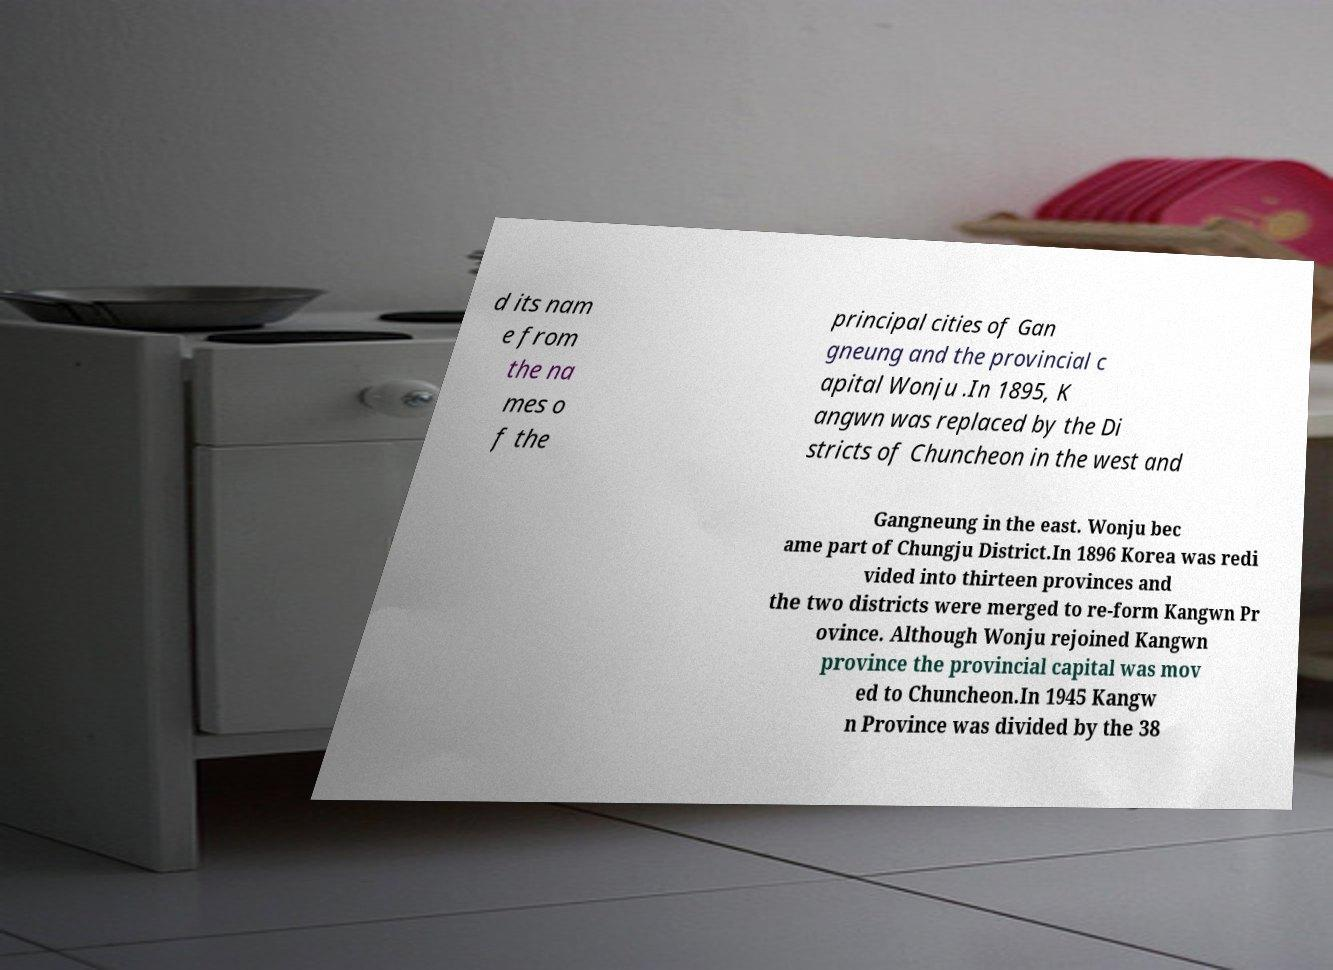Could you extract and type out the text from this image? d its nam e from the na mes o f the principal cities of Gan gneung and the provincial c apital Wonju .In 1895, K angwn was replaced by the Di stricts of Chuncheon in the west and Gangneung in the east. Wonju bec ame part of Chungju District.In 1896 Korea was redi vided into thirteen provinces and the two districts were merged to re-form Kangwn Pr ovince. Although Wonju rejoined Kangwn province the provincial capital was mov ed to Chuncheon.In 1945 Kangw n Province was divided by the 38 